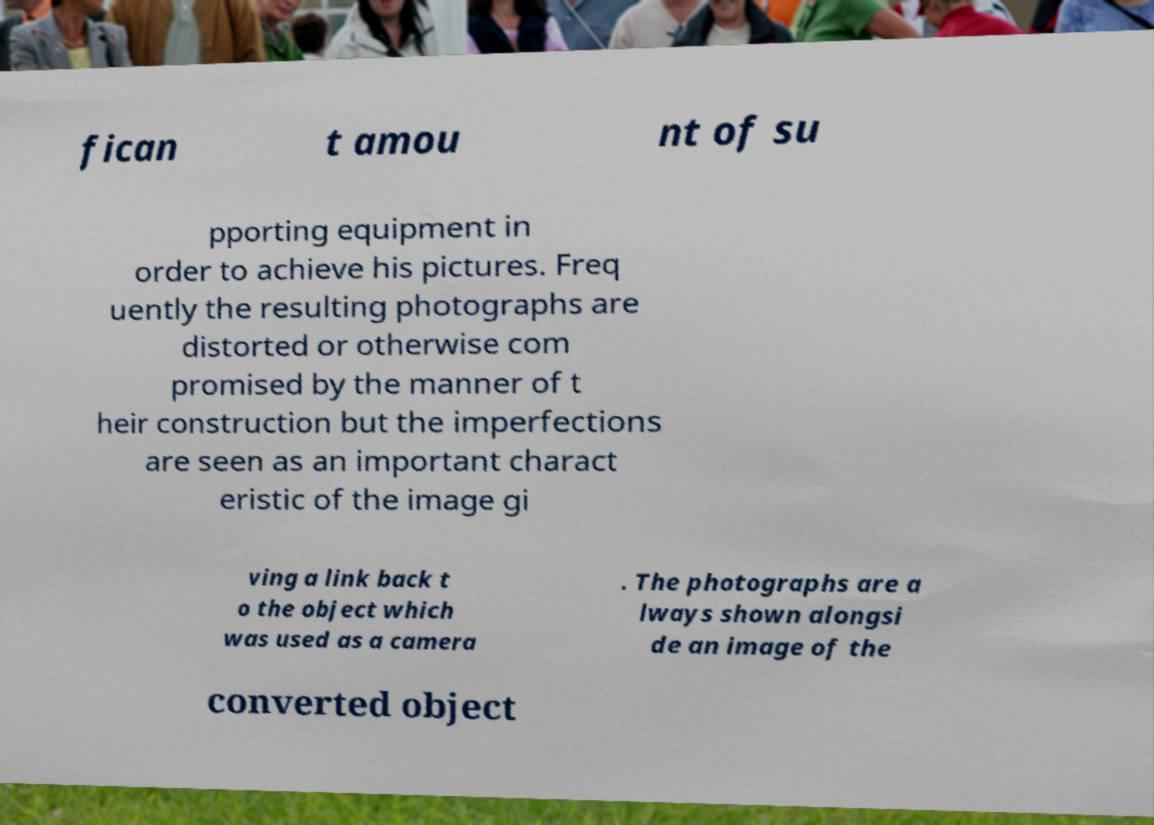I need the written content from this picture converted into text. Can you do that? fican t amou nt of su pporting equipment in order to achieve his pictures. Freq uently the resulting photographs are distorted or otherwise com promised by the manner of t heir construction but the imperfections are seen as an important charact eristic of the image gi ving a link back t o the object which was used as a camera . The photographs are a lways shown alongsi de an image of the converted object 